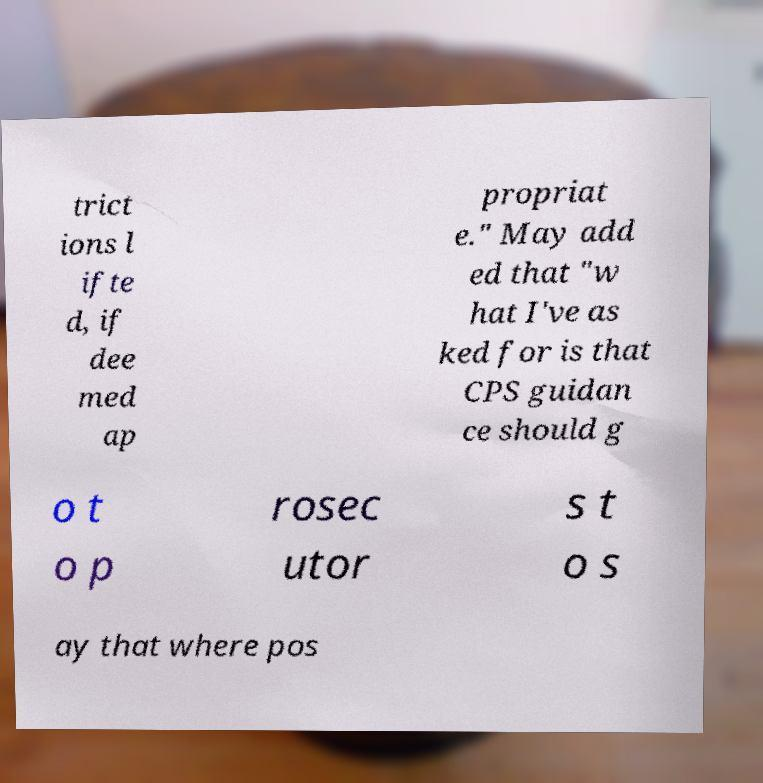For documentation purposes, I need the text within this image transcribed. Could you provide that? trict ions l ifte d, if dee med ap propriat e." May add ed that "w hat I've as ked for is that CPS guidan ce should g o t o p rosec utor s t o s ay that where pos 